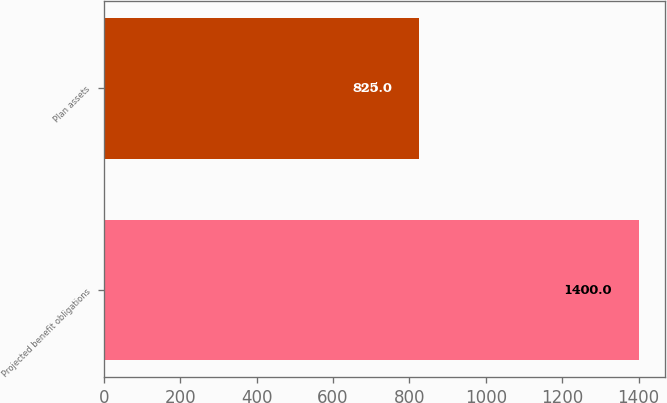Convert chart. <chart><loc_0><loc_0><loc_500><loc_500><bar_chart><fcel>Projected benefit obligations<fcel>Plan assets<nl><fcel>1400<fcel>825<nl></chart> 